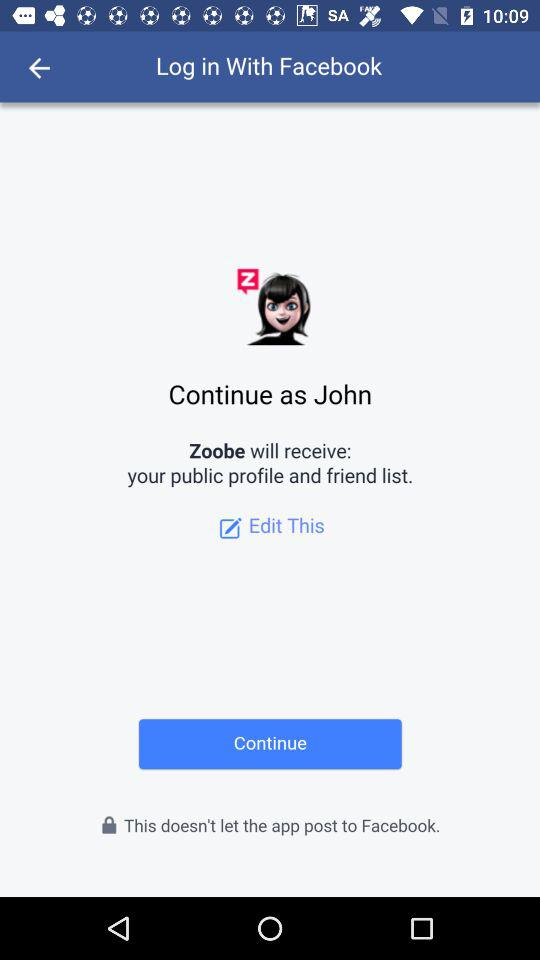Through what applications can we log in? We can log in through "Facebook". 